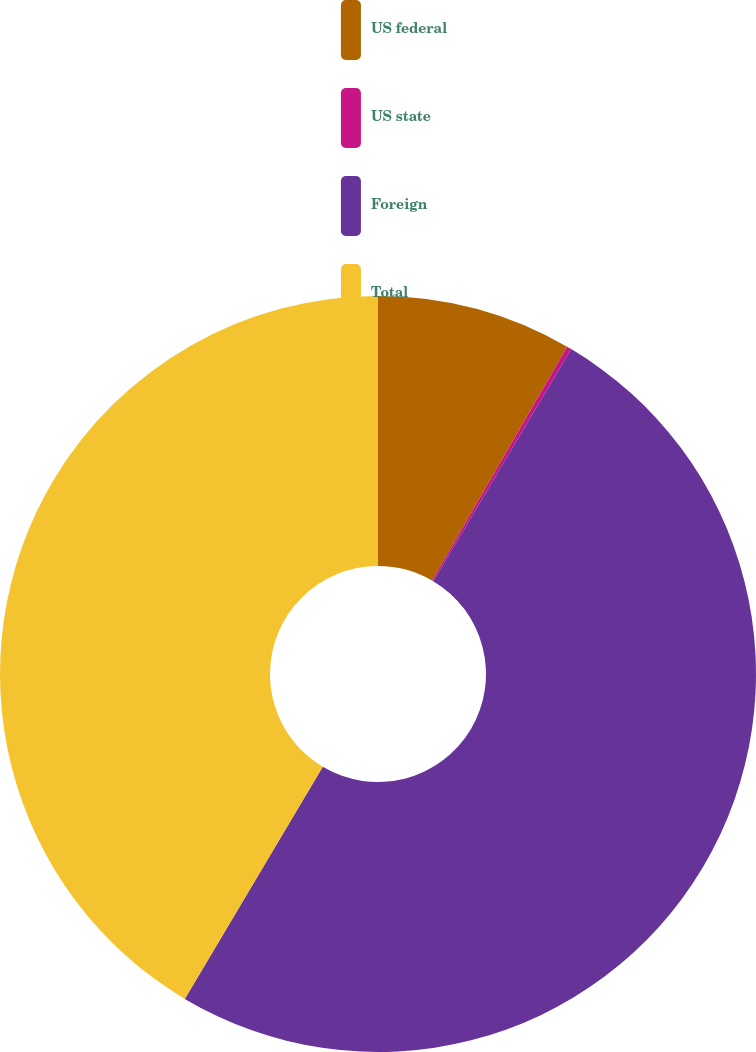Convert chart to OTSL. <chart><loc_0><loc_0><loc_500><loc_500><pie_chart><fcel>US federal<fcel>US state<fcel>Foreign<fcel>Total<nl><fcel>8.34%<fcel>0.2%<fcel>50.0%<fcel>41.46%<nl></chart> 